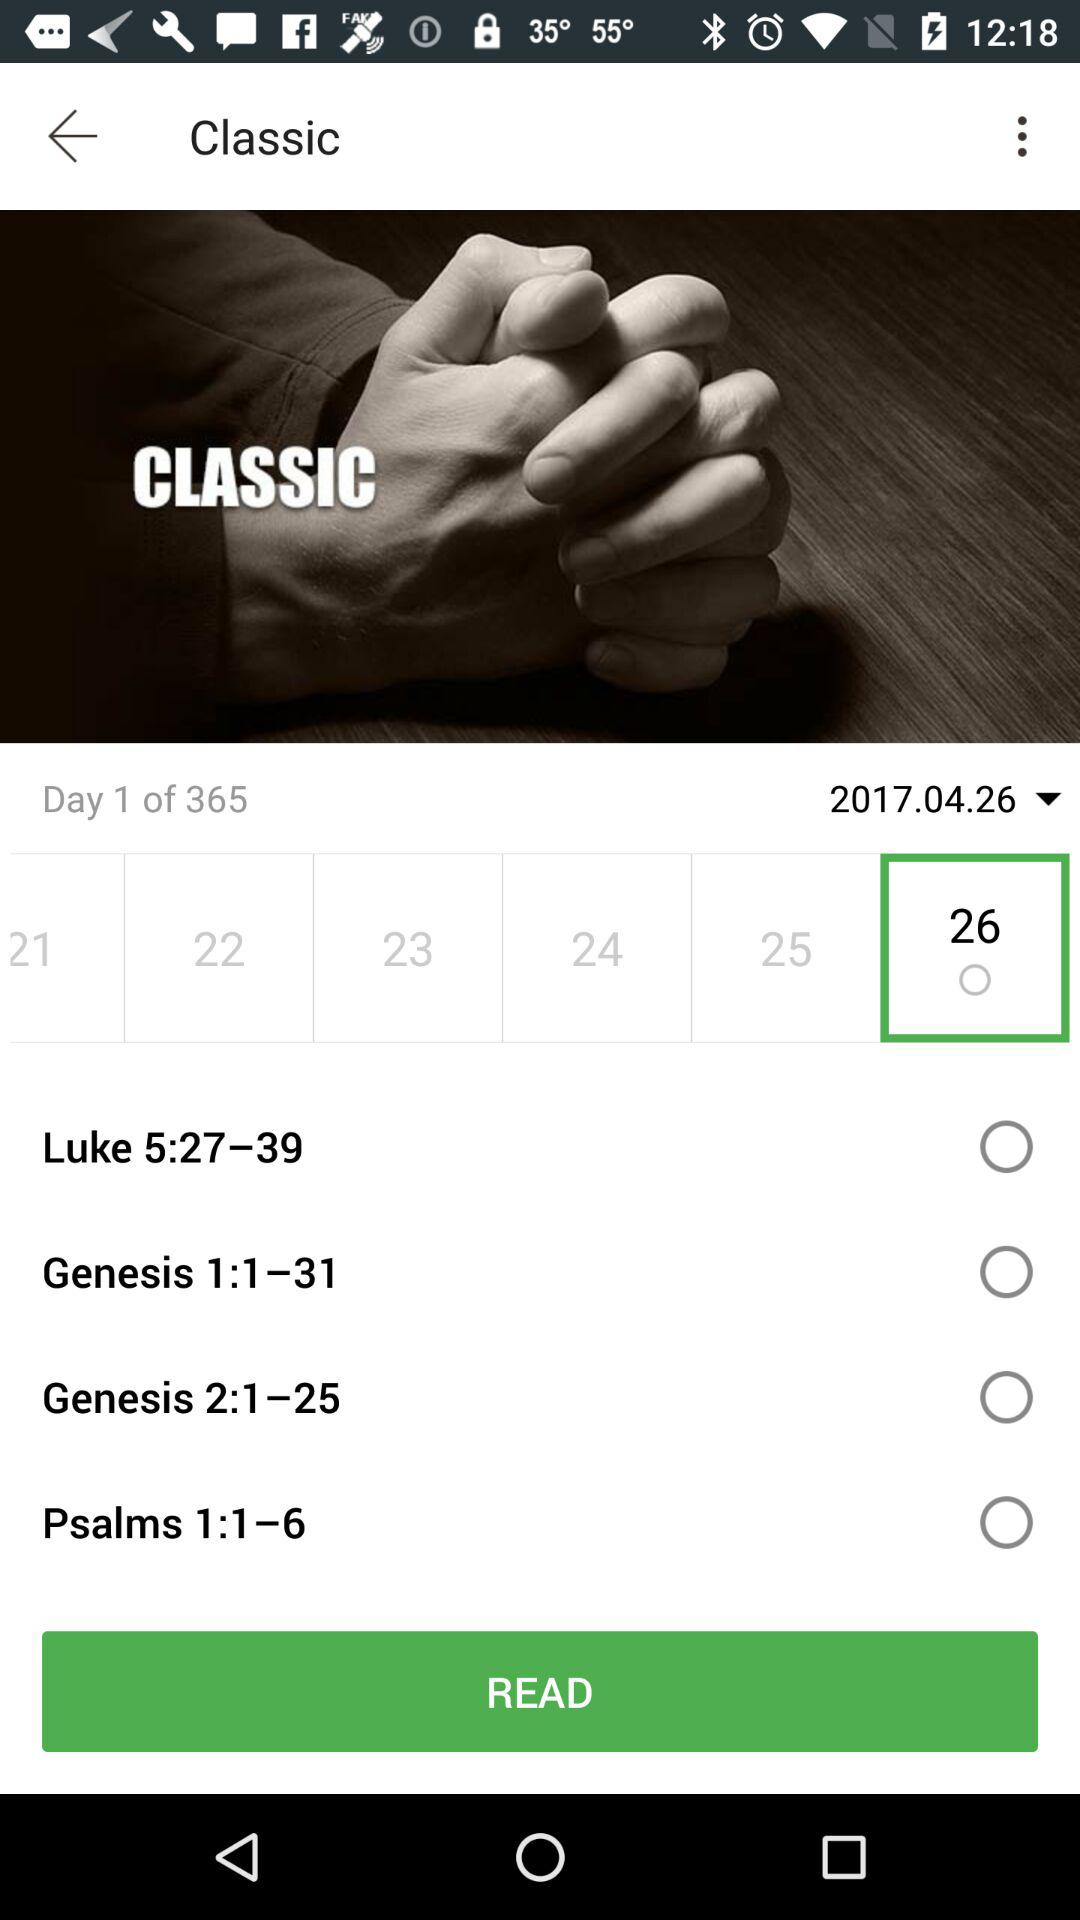What is the total number of days? The total number of days is 365. 